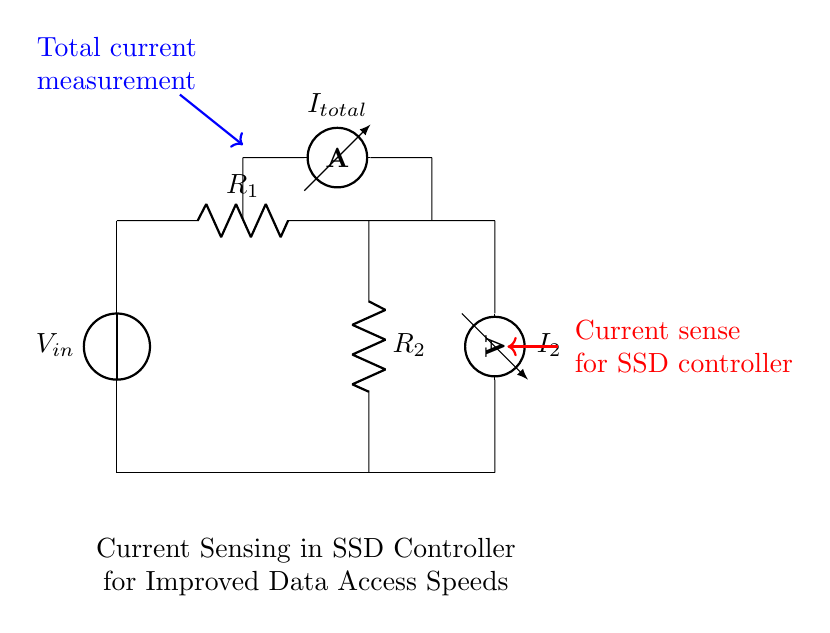What is the input voltage of the circuit? The input voltage is represented by the voltage source labeled V_in at the top of the circuit. It provides the voltage for the entire circuit.
Answer: V_in What are the resistances in the circuit? The circuit contains two resistors, labeled R_1 and R_2, which are connected in series. Their resistance values can be referenced directly by their labels.
Answer: R_1 and R_2 What does I_total represent in the circuit? I_total is labeled with an ammeter at the node where the two resistors meet. It represents the total current flowing into the parallel paths created by the resistors.
Answer: Total current What is the relationship between I_1 and I_2 in this circuit? I_1 and I_2 represent the currents through R_1 and R_2, respectively. In a current divider, the current through each resistor is inversely proportional to its resistance, which is the fundamental principle that governs their relationship.
Answer: I_1 and I_2 are inversely proportional to R_1 and R_2 How does current sensing improve data access speeds in SSD controllers? By measuring the current flowing through the circuit, the SSD controller can monitor power consumption and thermal conditions. This real-time data enables dynamic adjustments to optimize performance and access times based on current activity levels.
Answer: Improved performance through real-time monitoring 